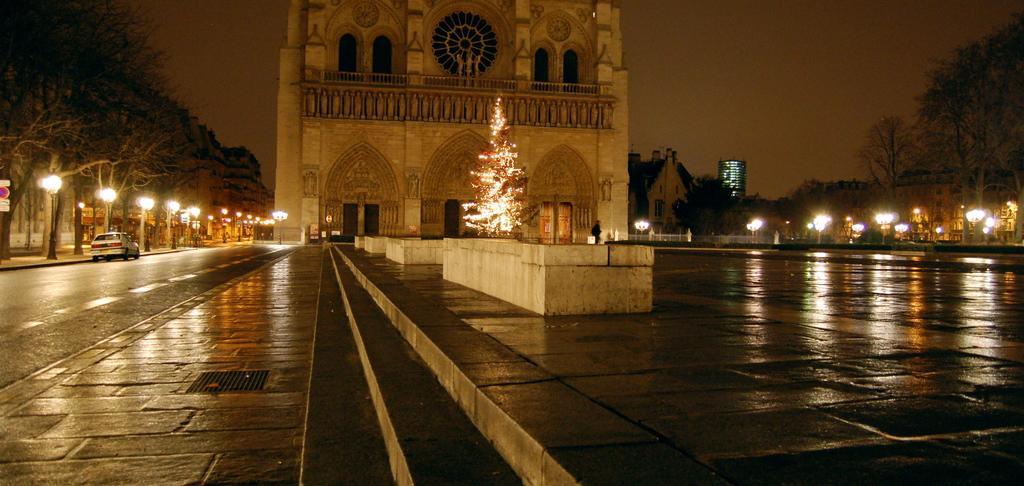Describe this image in one or two sentences. On the left side there is a road with a car on that. Near to that there are light poles and trees. There is a building with windows, railings and doors. In front of the building there is a tree with light decorations. On the right side there are light poles, trees and buildings. In the background there is sky. 